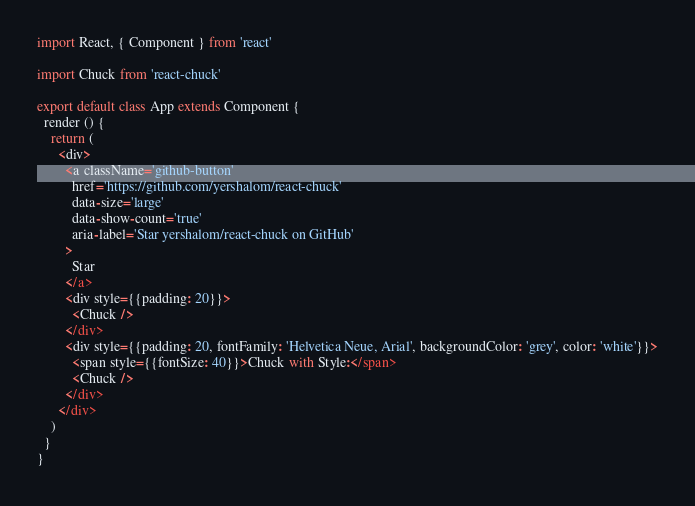Convert code to text. <code><loc_0><loc_0><loc_500><loc_500><_JavaScript_>import React, { Component } from 'react'

import Chuck from 'react-chuck'

export default class App extends Component {
  render () {
    return (
      <div>
        <a className='github-button'
          href='https://github.com/yershalom/react-chuck'
          data-size='large'
          data-show-count='true'
          aria-label='Star yershalom/react-chuck on GitHub'
        >
          Star
        </a>
        <div style={{padding: 20}}>
          <Chuck />
        </div>
        <div style={{padding: 20, fontFamily: 'Helvetica Neue, Arial', backgroundColor: 'grey', color: 'white'}}>
          <span style={{fontSize: 40}}>Chuck with Style:</span>
          <Chuck />
        </div>
      </div>
    )
  }
}
</code> 